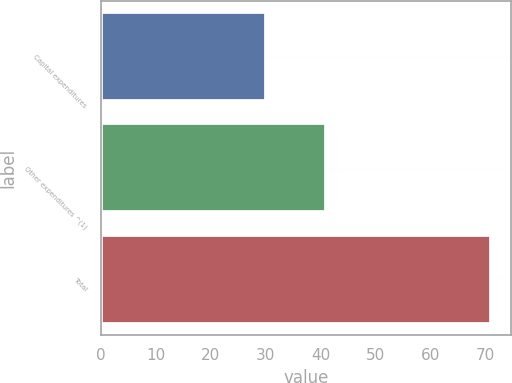Convert chart. <chart><loc_0><loc_0><loc_500><loc_500><bar_chart><fcel>Capital expenditures<fcel>Other expenditures ^(1)<fcel>Total<nl><fcel>30<fcel>41<fcel>71<nl></chart> 